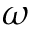Convert formula to latex. <formula><loc_0><loc_0><loc_500><loc_500>\omega</formula> 